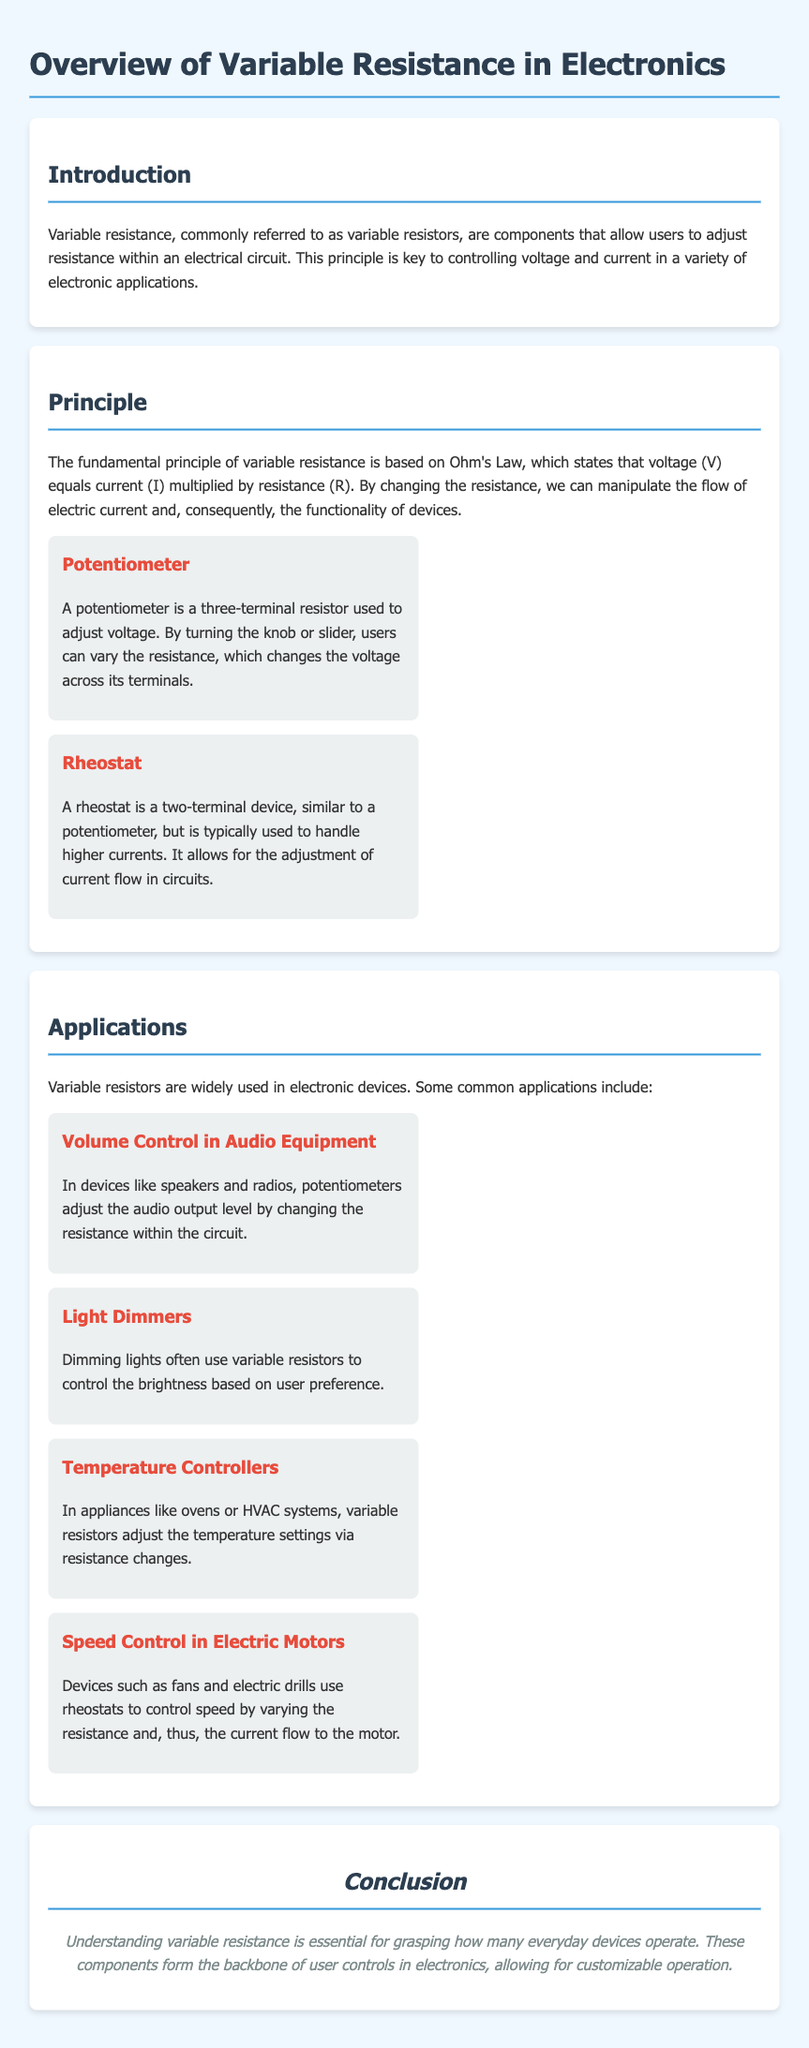What is a variable resistor? A variable resistor is a component that allows users to adjust resistance within an electrical circuit.
Answer: A component that allows users to adjust resistance What theorem is the principle of variable resistance based on? The principle of variable resistance is based on Ohm's Law, which states that voltage equals current multiplied by resistance.
Answer: Ohm's Law What type of variable resistor is used to adjust voltage? A potentiometer is used to adjust voltage.
Answer: Potentiometer Which application uses variable resistance to control brightness? Light dimmers use variable resistance to control brightness based on user preference.
Answer: Light Dimmers What type of variable resistor is typically used to handle higher currents? A rheostat is typically used to handle higher currents.
Answer: Rheostat What component helps control audio output levels? Potentiometers adjust the audio output level.
Answer: Potentiometers What is one common use of rheostats in electronic devices? Rheostats are used to control speed in electric motors.
Answer: Control speed in electric motors What is the importance of understanding variable resistance? Understanding variable resistance is essential for grasping how many everyday devices operate.
Answer: Essential for understanding everyday devices 